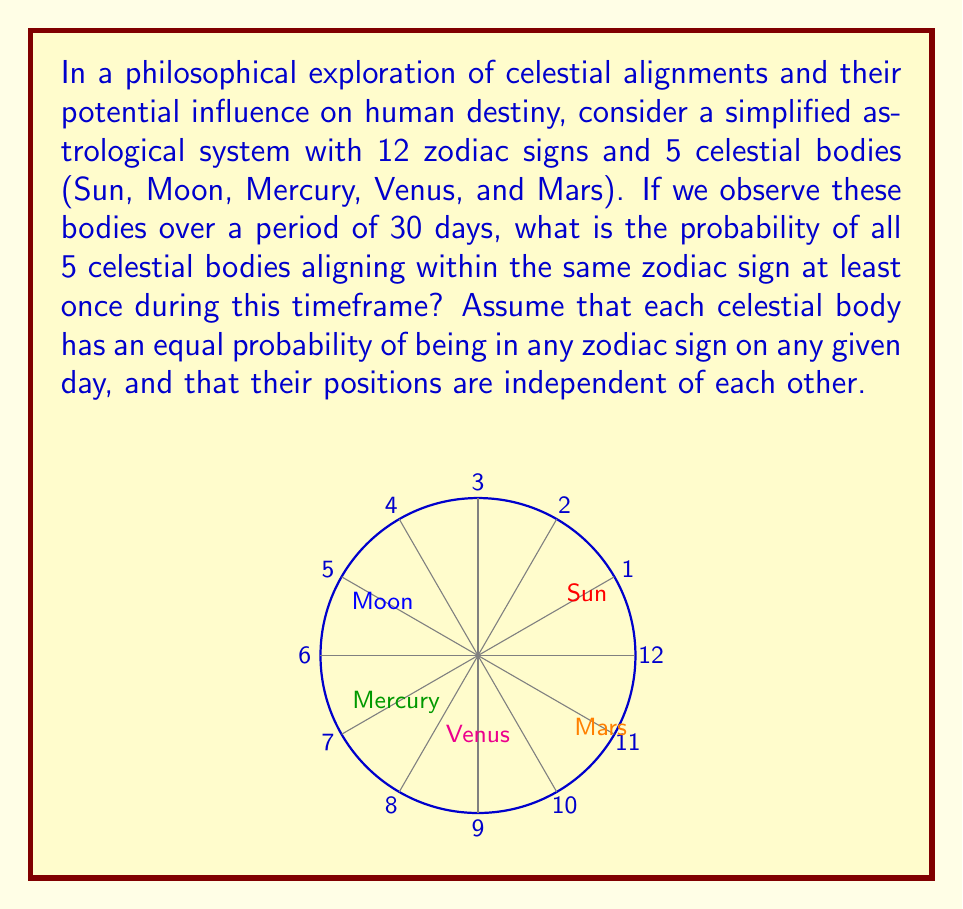Teach me how to tackle this problem. Let's approach this step-by-step:

1) First, we need to calculate the probability of all 5 celestial bodies being in the same zodiac sign on a single day.
   - The probability of one body being in a specific sign is $\frac{1}{12}$.
   - For all 5 bodies to be in the same sign, we multiply these probabilities:
     $$P(\text{alignment on one day}) = \left(\frac{1}{12}\right)^5 = \frac{1}{248,832}$$

2) Now, we need to find the probability of this not happening on a single day:
   $$P(\text{no alignment on one day}) = 1 - \frac{1}{248,832} = \frac{248,831}{248,832}$$

3) For no alignment to occur over 30 days, this must happen every day:
   $$P(\text{no alignment over 30 days}) = \left(\frac{248,831}{248,832}\right)^{30}$$

4) Therefore, the probability of at least one alignment occurring in 30 days is:
   $$P(\text{at least one alignment in 30 days}) = 1 - \left(\frac{248,831}{248,832}\right)^{30}$$

5) Calculating this:
   $$1 - \left(\frac{248,831}{248,832}\right)^{30} \approx 0.0001204 = 1.204 \times 10^{-4}$$

This small probability might lead a philosopher to ponder the rarity of such alignments and their potential significance in human perception of destiny.
Answer: $1.204 \times 10^{-4}$ 